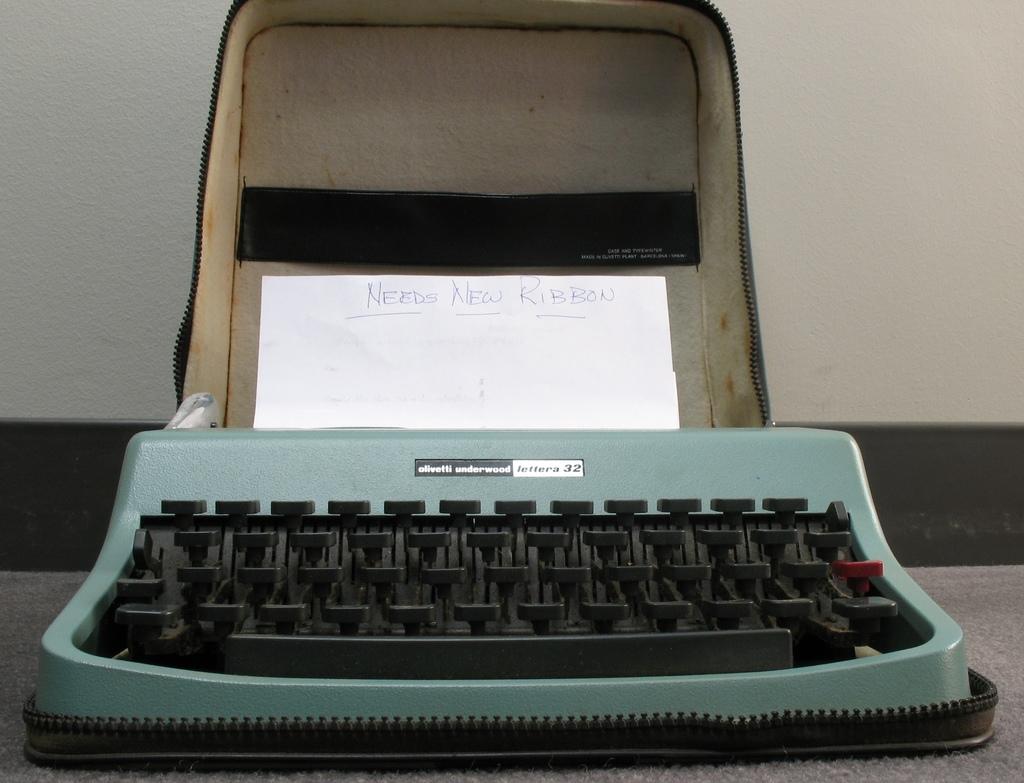What does the piece of paper say?
Provide a succinct answer. Needs new ribbon. What brand of typewriter is this?
Keep it short and to the point. Olivetti underwood. 